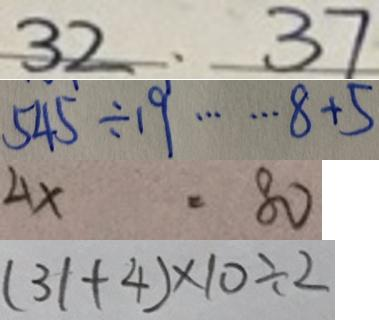Convert formula to latex. <formula><loc_0><loc_0><loc_500><loc_500>3 2 、 3 7 
 5 4 5 \div 1 9 \cdots 8 + 5 
 4 x \cdot 8 0 
 ( 3 1 + 4 ) \times 1 0 \div 2</formula> 